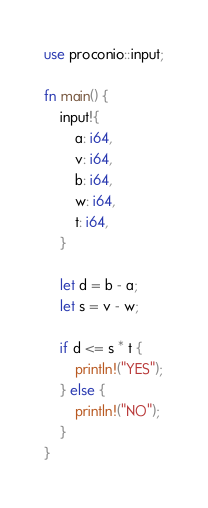<code> <loc_0><loc_0><loc_500><loc_500><_Rust_>use proconio::input;

fn main() {
    input!{
        a: i64,
        v: i64,
        b: i64,
        w: i64,
        t: i64,
    }
    
    let d = b - a;
    let s = v - w;

    if d <= s * t {
        println!("YES");
    } else {
        println!("NO");
    }
}
</code> 